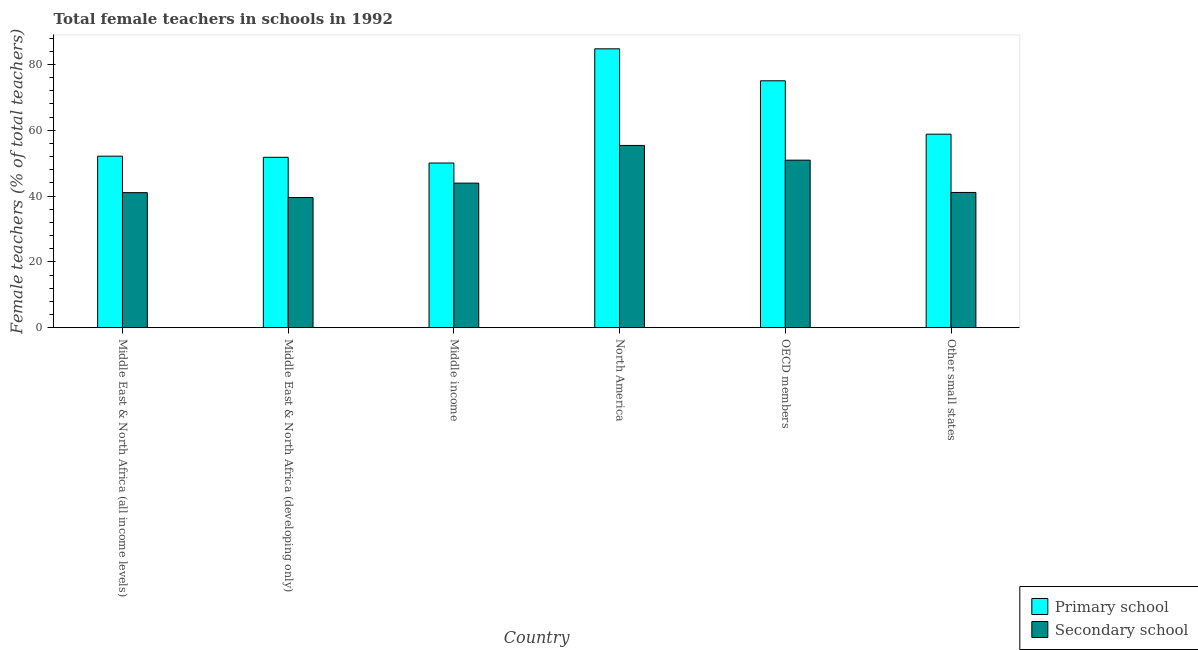How many different coloured bars are there?
Your answer should be compact. 2. How many bars are there on the 2nd tick from the left?
Offer a very short reply. 2. What is the label of the 4th group of bars from the left?
Your answer should be compact. North America. What is the percentage of female teachers in primary schools in Other small states?
Your answer should be compact. 58.81. Across all countries, what is the maximum percentage of female teachers in secondary schools?
Your answer should be very brief. 55.38. Across all countries, what is the minimum percentage of female teachers in primary schools?
Your answer should be very brief. 50.04. In which country was the percentage of female teachers in secondary schools minimum?
Offer a terse response. Middle East & North Africa (developing only). What is the total percentage of female teachers in secondary schools in the graph?
Keep it short and to the point. 271.9. What is the difference between the percentage of female teachers in secondary schools in Middle East & North Africa (developing only) and that in North America?
Provide a short and direct response. -15.84. What is the difference between the percentage of female teachers in secondary schools in Middle income and the percentage of female teachers in primary schools in Other small states?
Keep it short and to the point. -14.88. What is the average percentage of female teachers in primary schools per country?
Offer a very short reply. 62.09. What is the difference between the percentage of female teachers in primary schools and percentage of female teachers in secondary schools in Middle income?
Offer a very short reply. 6.11. In how many countries, is the percentage of female teachers in primary schools greater than 80 %?
Your answer should be very brief. 1. What is the ratio of the percentage of female teachers in primary schools in Middle East & North Africa (developing only) to that in North America?
Provide a succinct answer. 0.61. Is the percentage of female teachers in primary schools in Middle income less than that in North America?
Your response must be concise. Yes. What is the difference between the highest and the second highest percentage of female teachers in primary schools?
Offer a terse response. 9.72. What is the difference between the highest and the lowest percentage of female teachers in secondary schools?
Your response must be concise. 15.84. What does the 1st bar from the left in Middle East & North Africa (all income levels) represents?
Your answer should be very brief. Primary school. What does the 2nd bar from the right in Middle East & North Africa (developing only) represents?
Keep it short and to the point. Primary school. How many countries are there in the graph?
Your answer should be compact. 6. Where does the legend appear in the graph?
Your answer should be very brief. Bottom right. How many legend labels are there?
Provide a short and direct response. 2. What is the title of the graph?
Give a very brief answer. Total female teachers in schools in 1992. What is the label or title of the Y-axis?
Give a very brief answer. Female teachers (% of total teachers). What is the Female teachers (% of total teachers) of Primary school in Middle East & North Africa (all income levels)?
Provide a succinct answer. 52.12. What is the Female teachers (% of total teachers) in Secondary school in Middle East & North Africa (all income levels)?
Keep it short and to the point. 41.04. What is the Female teachers (% of total teachers) of Primary school in Middle East & North Africa (developing only)?
Your answer should be compact. 51.78. What is the Female teachers (% of total teachers) of Secondary school in Middle East & North Africa (developing only)?
Offer a terse response. 39.55. What is the Female teachers (% of total teachers) of Primary school in Middle income?
Offer a terse response. 50.04. What is the Female teachers (% of total teachers) in Secondary school in Middle income?
Give a very brief answer. 43.93. What is the Female teachers (% of total teachers) in Primary school in North America?
Offer a very short reply. 84.75. What is the Female teachers (% of total teachers) of Secondary school in North America?
Offer a terse response. 55.38. What is the Female teachers (% of total teachers) of Primary school in OECD members?
Your response must be concise. 75.03. What is the Female teachers (% of total teachers) in Secondary school in OECD members?
Make the answer very short. 50.91. What is the Female teachers (% of total teachers) in Primary school in Other small states?
Ensure brevity in your answer.  58.81. What is the Female teachers (% of total teachers) in Secondary school in Other small states?
Offer a terse response. 41.1. Across all countries, what is the maximum Female teachers (% of total teachers) in Primary school?
Give a very brief answer. 84.75. Across all countries, what is the maximum Female teachers (% of total teachers) of Secondary school?
Make the answer very short. 55.38. Across all countries, what is the minimum Female teachers (% of total teachers) of Primary school?
Offer a terse response. 50.04. Across all countries, what is the minimum Female teachers (% of total teachers) in Secondary school?
Offer a terse response. 39.55. What is the total Female teachers (% of total teachers) in Primary school in the graph?
Provide a succinct answer. 372.54. What is the total Female teachers (% of total teachers) in Secondary school in the graph?
Provide a short and direct response. 271.9. What is the difference between the Female teachers (% of total teachers) in Primary school in Middle East & North Africa (all income levels) and that in Middle East & North Africa (developing only)?
Make the answer very short. 0.35. What is the difference between the Female teachers (% of total teachers) of Secondary school in Middle East & North Africa (all income levels) and that in Middle East & North Africa (developing only)?
Give a very brief answer. 1.49. What is the difference between the Female teachers (% of total teachers) in Primary school in Middle East & North Africa (all income levels) and that in Middle income?
Provide a short and direct response. 2.08. What is the difference between the Female teachers (% of total teachers) of Secondary school in Middle East & North Africa (all income levels) and that in Middle income?
Offer a terse response. -2.89. What is the difference between the Female teachers (% of total teachers) in Primary school in Middle East & North Africa (all income levels) and that in North America?
Make the answer very short. -32.63. What is the difference between the Female teachers (% of total teachers) in Secondary school in Middle East & North Africa (all income levels) and that in North America?
Give a very brief answer. -14.35. What is the difference between the Female teachers (% of total teachers) in Primary school in Middle East & North Africa (all income levels) and that in OECD members?
Offer a terse response. -22.91. What is the difference between the Female teachers (% of total teachers) of Secondary school in Middle East & North Africa (all income levels) and that in OECD members?
Offer a very short reply. -9.87. What is the difference between the Female teachers (% of total teachers) of Primary school in Middle East & North Africa (all income levels) and that in Other small states?
Keep it short and to the point. -6.69. What is the difference between the Female teachers (% of total teachers) in Secondary school in Middle East & North Africa (all income levels) and that in Other small states?
Provide a short and direct response. -0.06. What is the difference between the Female teachers (% of total teachers) in Primary school in Middle East & North Africa (developing only) and that in Middle income?
Keep it short and to the point. 1.74. What is the difference between the Female teachers (% of total teachers) of Secondary school in Middle East & North Africa (developing only) and that in Middle income?
Provide a succinct answer. -4.38. What is the difference between the Female teachers (% of total teachers) in Primary school in Middle East & North Africa (developing only) and that in North America?
Offer a very short reply. -32.98. What is the difference between the Female teachers (% of total teachers) in Secondary school in Middle East & North Africa (developing only) and that in North America?
Keep it short and to the point. -15.84. What is the difference between the Female teachers (% of total teachers) in Primary school in Middle East & North Africa (developing only) and that in OECD members?
Provide a succinct answer. -23.26. What is the difference between the Female teachers (% of total teachers) in Secondary school in Middle East & North Africa (developing only) and that in OECD members?
Provide a short and direct response. -11.36. What is the difference between the Female teachers (% of total teachers) of Primary school in Middle East & North Africa (developing only) and that in Other small states?
Provide a short and direct response. -7.03. What is the difference between the Female teachers (% of total teachers) in Secondary school in Middle East & North Africa (developing only) and that in Other small states?
Offer a very short reply. -1.55. What is the difference between the Female teachers (% of total teachers) of Primary school in Middle income and that in North America?
Your response must be concise. -34.71. What is the difference between the Female teachers (% of total teachers) of Secondary school in Middle income and that in North America?
Offer a very short reply. -11.46. What is the difference between the Female teachers (% of total teachers) in Primary school in Middle income and that in OECD members?
Keep it short and to the point. -24.99. What is the difference between the Female teachers (% of total teachers) of Secondary school in Middle income and that in OECD members?
Your response must be concise. -6.98. What is the difference between the Female teachers (% of total teachers) in Primary school in Middle income and that in Other small states?
Your response must be concise. -8.77. What is the difference between the Female teachers (% of total teachers) in Secondary school in Middle income and that in Other small states?
Provide a succinct answer. 2.83. What is the difference between the Female teachers (% of total teachers) of Primary school in North America and that in OECD members?
Offer a very short reply. 9.72. What is the difference between the Female teachers (% of total teachers) in Secondary school in North America and that in OECD members?
Your answer should be very brief. 4.47. What is the difference between the Female teachers (% of total teachers) in Primary school in North America and that in Other small states?
Keep it short and to the point. 25.94. What is the difference between the Female teachers (% of total teachers) in Secondary school in North America and that in Other small states?
Offer a terse response. 14.28. What is the difference between the Female teachers (% of total teachers) of Primary school in OECD members and that in Other small states?
Make the answer very short. 16.22. What is the difference between the Female teachers (% of total teachers) in Secondary school in OECD members and that in Other small states?
Your response must be concise. 9.81. What is the difference between the Female teachers (% of total teachers) in Primary school in Middle East & North Africa (all income levels) and the Female teachers (% of total teachers) in Secondary school in Middle East & North Africa (developing only)?
Keep it short and to the point. 12.58. What is the difference between the Female teachers (% of total teachers) in Primary school in Middle East & North Africa (all income levels) and the Female teachers (% of total teachers) in Secondary school in Middle income?
Ensure brevity in your answer.  8.2. What is the difference between the Female teachers (% of total teachers) of Primary school in Middle East & North Africa (all income levels) and the Female teachers (% of total teachers) of Secondary school in North America?
Your response must be concise. -3.26. What is the difference between the Female teachers (% of total teachers) in Primary school in Middle East & North Africa (all income levels) and the Female teachers (% of total teachers) in Secondary school in OECD members?
Provide a short and direct response. 1.21. What is the difference between the Female teachers (% of total teachers) of Primary school in Middle East & North Africa (all income levels) and the Female teachers (% of total teachers) of Secondary school in Other small states?
Provide a succinct answer. 11.02. What is the difference between the Female teachers (% of total teachers) in Primary school in Middle East & North Africa (developing only) and the Female teachers (% of total teachers) in Secondary school in Middle income?
Give a very brief answer. 7.85. What is the difference between the Female teachers (% of total teachers) of Primary school in Middle East & North Africa (developing only) and the Female teachers (% of total teachers) of Secondary school in North America?
Give a very brief answer. -3.61. What is the difference between the Female teachers (% of total teachers) of Primary school in Middle East & North Africa (developing only) and the Female teachers (% of total teachers) of Secondary school in OECD members?
Ensure brevity in your answer.  0.87. What is the difference between the Female teachers (% of total teachers) of Primary school in Middle East & North Africa (developing only) and the Female teachers (% of total teachers) of Secondary school in Other small states?
Keep it short and to the point. 10.68. What is the difference between the Female teachers (% of total teachers) in Primary school in Middle income and the Female teachers (% of total teachers) in Secondary school in North America?
Make the answer very short. -5.34. What is the difference between the Female teachers (% of total teachers) in Primary school in Middle income and the Female teachers (% of total teachers) in Secondary school in OECD members?
Offer a terse response. -0.87. What is the difference between the Female teachers (% of total teachers) of Primary school in Middle income and the Female teachers (% of total teachers) of Secondary school in Other small states?
Give a very brief answer. 8.94. What is the difference between the Female teachers (% of total teachers) of Primary school in North America and the Female teachers (% of total teachers) of Secondary school in OECD members?
Offer a very short reply. 33.84. What is the difference between the Female teachers (% of total teachers) in Primary school in North America and the Female teachers (% of total teachers) in Secondary school in Other small states?
Keep it short and to the point. 43.65. What is the difference between the Female teachers (% of total teachers) in Primary school in OECD members and the Female teachers (% of total teachers) in Secondary school in Other small states?
Make the answer very short. 33.94. What is the average Female teachers (% of total teachers) in Primary school per country?
Keep it short and to the point. 62.09. What is the average Female teachers (% of total teachers) in Secondary school per country?
Your answer should be very brief. 45.32. What is the difference between the Female teachers (% of total teachers) in Primary school and Female teachers (% of total teachers) in Secondary school in Middle East & North Africa (all income levels)?
Your response must be concise. 11.09. What is the difference between the Female teachers (% of total teachers) of Primary school and Female teachers (% of total teachers) of Secondary school in Middle East & North Africa (developing only)?
Offer a terse response. 12.23. What is the difference between the Female teachers (% of total teachers) in Primary school and Female teachers (% of total teachers) in Secondary school in Middle income?
Ensure brevity in your answer.  6.11. What is the difference between the Female teachers (% of total teachers) in Primary school and Female teachers (% of total teachers) in Secondary school in North America?
Offer a very short reply. 29.37. What is the difference between the Female teachers (% of total teachers) in Primary school and Female teachers (% of total teachers) in Secondary school in OECD members?
Offer a terse response. 24.12. What is the difference between the Female teachers (% of total teachers) of Primary school and Female teachers (% of total teachers) of Secondary school in Other small states?
Your response must be concise. 17.71. What is the ratio of the Female teachers (% of total teachers) of Primary school in Middle East & North Africa (all income levels) to that in Middle East & North Africa (developing only)?
Ensure brevity in your answer.  1.01. What is the ratio of the Female teachers (% of total teachers) of Secondary school in Middle East & North Africa (all income levels) to that in Middle East & North Africa (developing only)?
Give a very brief answer. 1.04. What is the ratio of the Female teachers (% of total teachers) in Primary school in Middle East & North Africa (all income levels) to that in Middle income?
Keep it short and to the point. 1.04. What is the ratio of the Female teachers (% of total teachers) in Secondary school in Middle East & North Africa (all income levels) to that in Middle income?
Give a very brief answer. 0.93. What is the ratio of the Female teachers (% of total teachers) of Primary school in Middle East & North Africa (all income levels) to that in North America?
Give a very brief answer. 0.61. What is the ratio of the Female teachers (% of total teachers) in Secondary school in Middle East & North Africa (all income levels) to that in North America?
Your answer should be compact. 0.74. What is the ratio of the Female teachers (% of total teachers) of Primary school in Middle East & North Africa (all income levels) to that in OECD members?
Offer a terse response. 0.69. What is the ratio of the Female teachers (% of total teachers) in Secondary school in Middle East & North Africa (all income levels) to that in OECD members?
Your answer should be very brief. 0.81. What is the ratio of the Female teachers (% of total teachers) of Primary school in Middle East & North Africa (all income levels) to that in Other small states?
Keep it short and to the point. 0.89. What is the ratio of the Female teachers (% of total teachers) of Secondary school in Middle East & North Africa (all income levels) to that in Other small states?
Keep it short and to the point. 1. What is the ratio of the Female teachers (% of total teachers) of Primary school in Middle East & North Africa (developing only) to that in Middle income?
Your answer should be compact. 1.03. What is the ratio of the Female teachers (% of total teachers) of Secondary school in Middle East & North Africa (developing only) to that in Middle income?
Offer a very short reply. 0.9. What is the ratio of the Female teachers (% of total teachers) of Primary school in Middle East & North Africa (developing only) to that in North America?
Your answer should be compact. 0.61. What is the ratio of the Female teachers (% of total teachers) in Secondary school in Middle East & North Africa (developing only) to that in North America?
Your answer should be very brief. 0.71. What is the ratio of the Female teachers (% of total teachers) of Primary school in Middle East & North Africa (developing only) to that in OECD members?
Keep it short and to the point. 0.69. What is the ratio of the Female teachers (% of total teachers) in Secondary school in Middle East & North Africa (developing only) to that in OECD members?
Your answer should be very brief. 0.78. What is the ratio of the Female teachers (% of total teachers) in Primary school in Middle East & North Africa (developing only) to that in Other small states?
Provide a short and direct response. 0.88. What is the ratio of the Female teachers (% of total teachers) of Secondary school in Middle East & North Africa (developing only) to that in Other small states?
Give a very brief answer. 0.96. What is the ratio of the Female teachers (% of total teachers) of Primary school in Middle income to that in North America?
Offer a very short reply. 0.59. What is the ratio of the Female teachers (% of total teachers) in Secondary school in Middle income to that in North America?
Provide a short and direct response. 0.79. What is the ratio of the Female teachers (% of total teachers) of Primary school in Middle income to that in OECD members?
Provide a succinct answer. 0.67. What is the ratio of the Female teachers (% of total teachers) in Secondary school in Middle income to that in OECD members?
Your answer should be compact. 0.86. What is the ratio of the Female teachers (% of total teachers) of Primary school in Middle income to that in Other small states?
Make the answer very short. 0.85. What is the ratio of the Female teachers (% of total teachers) of Secondary school in Middle income to that in Other small states?
Make the answer very short. 1.07. What is the ratio of the Female teachers (% of total teachers) of Primary school in North America to that in OECD members?
Keep it short and to the point. 1.13. What is the ratio of the Female teachers (% of total teachers) of Secondary school in North America to that in OECD members?
Offer a very short reply. 1.09. What is the ratio of the Female teachers (% of total teachers) in Primary school in North America to that in Other small states?
Provide a short and direct response. 1.44. What is the ratio of the Female teachers (% of total teachers) in Secondary school in North America to that in Other small states?
Your answer should be very brief. 1.35. What is the ratio of the Female teachers (% of total teachers) in Primary school in OECD members to that in Other small states?
Make the answer very short. 1.28. What is the ratio of the Female teachers (% of total teachers) of Secondary school in OECD members to that in Other small states?
Give a very brief answer. 1.24. What is the difference between the highest and the second highest Female teachers (% of total teachers) in Primary school?
Your answer should be very brief. 9.72. What is the difference between the highest and the second highest Female teachers (% of total teachers) in Secondary school?
Provide a short and direct response. 4.47. What is the difference between the highest and the lowest Female teachers (% of total teachers) in Primary school?
Provide a short and direct response. 34.71. What is the difference between the highest and the lowest Female teachers (% of total teachers) of Secondary school?
Make the answer very short. 15.84. 